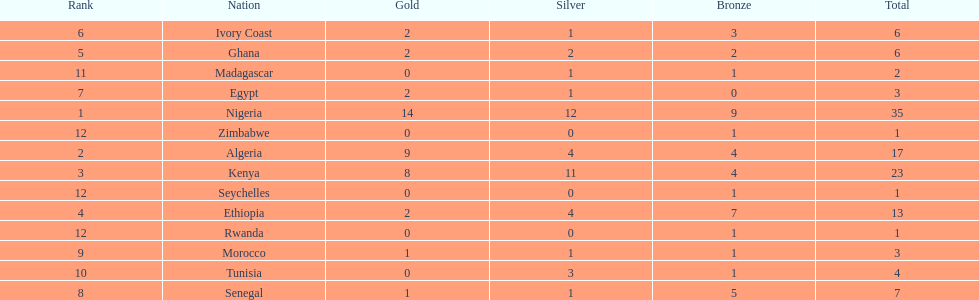What is the name of the only nation that did not earn any bronze medals? Egypt. 